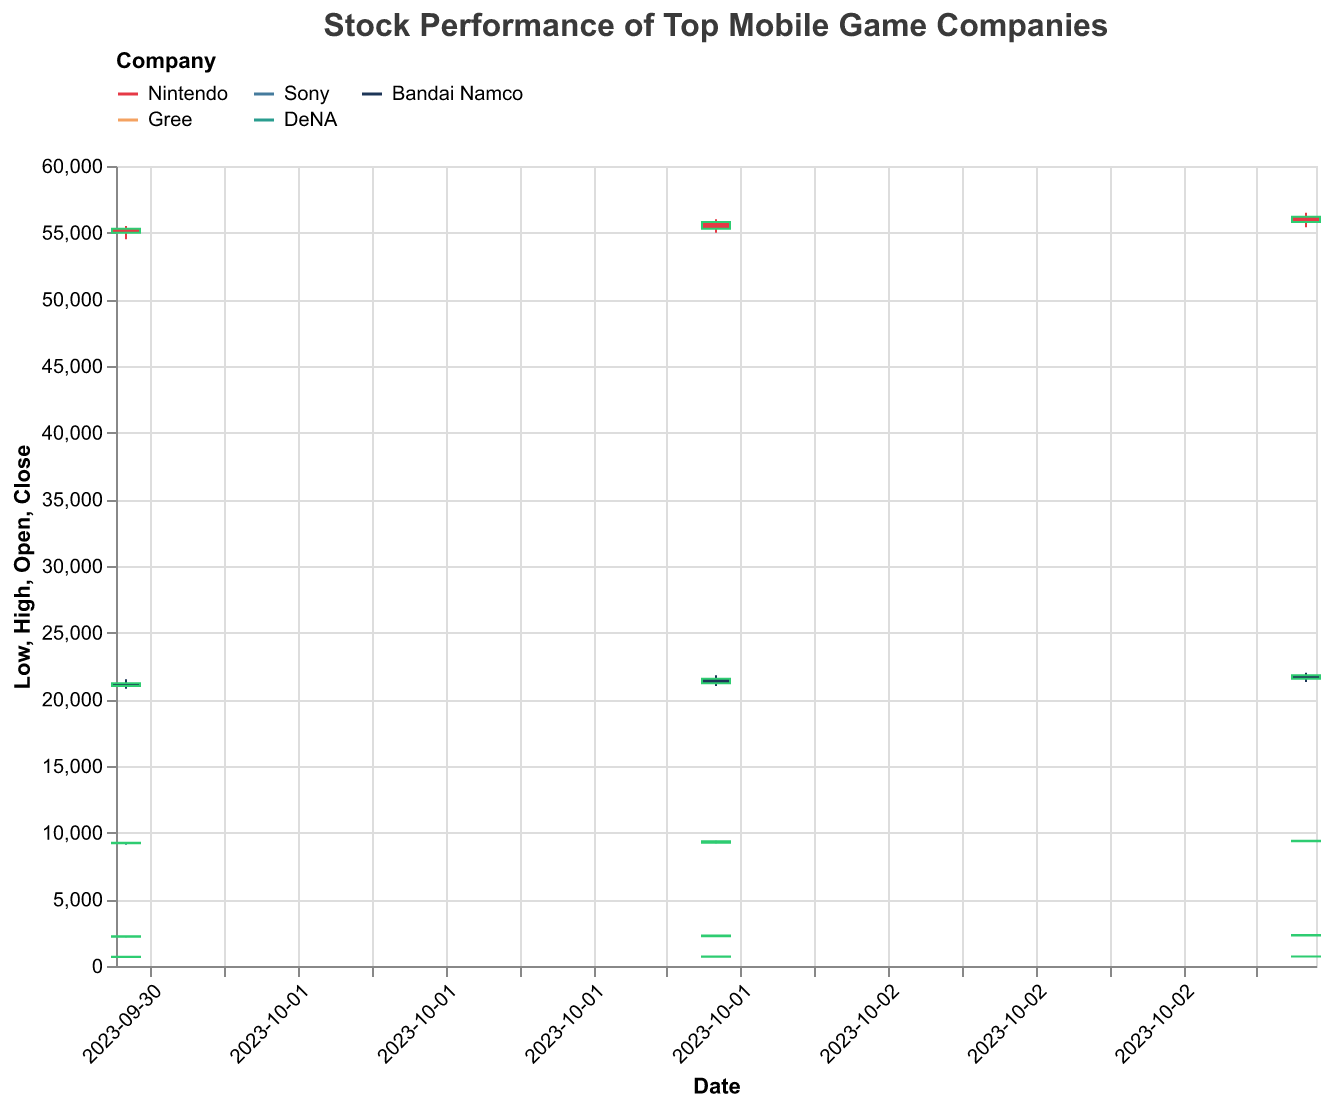What is the title of the plot? The title can be seen at the top of the plot, typically in bold and larger font size, indicating the subject of the visualization.
Answer: Stock Performance of Top Mobile Game Companies How many companies are displayed in the plot? The legend shows the listed companies, each represented by a different color. Counting those colors tells us the number of companies.
Answer: 5 Which company had the highest close price on 2023-10-03? Locate the candlestick on 2023-10-03 for each company and compare the closing prices (top of the real body for green bars, bottom for red bars).
Answer: Nintendo What was the closing price for Sony on 2023-10-01? Locate Sony’s candlestick on 2023-10-01 and refer to the close price, which is indicated at the top of the real body if the bar is green and at the bottom if it’s red.
Answer: 9250 Which day had the highest trading volume for DeNA? Look at the volume data associated with DeNA for each date and determine which has the largest number.
Answer: 2023-10-02 Which company showed the steepest increase in closing price over the three days? Calculate the difference in closing prices between 2023-10-03 and 2023-10-01 for each company. The largest positive difference indicates the steepest increase.
Answer: DeNA Which company had the narrowest range (high - low) on any given day? For each day, compute the range (high - low) for each company's stock. Find the smallest range across all observations.
Answer: Gree on 2023-10-03 Did any company experience a price drop from 2023-10-02 to 2023-10-03? Compare the closing prices for each company between 2023-10-02 and 2023-10-03. A drop would have the 2023-10-03 price lower than the 2023-10-02 price.
Answer: No Which company had the most significant difference between the opening and closing price on 2023-10-03? For each company, compute the absolute difference between the opening and closing prices on 2023-10-03 and find the largest value.
Answer: DeNA 